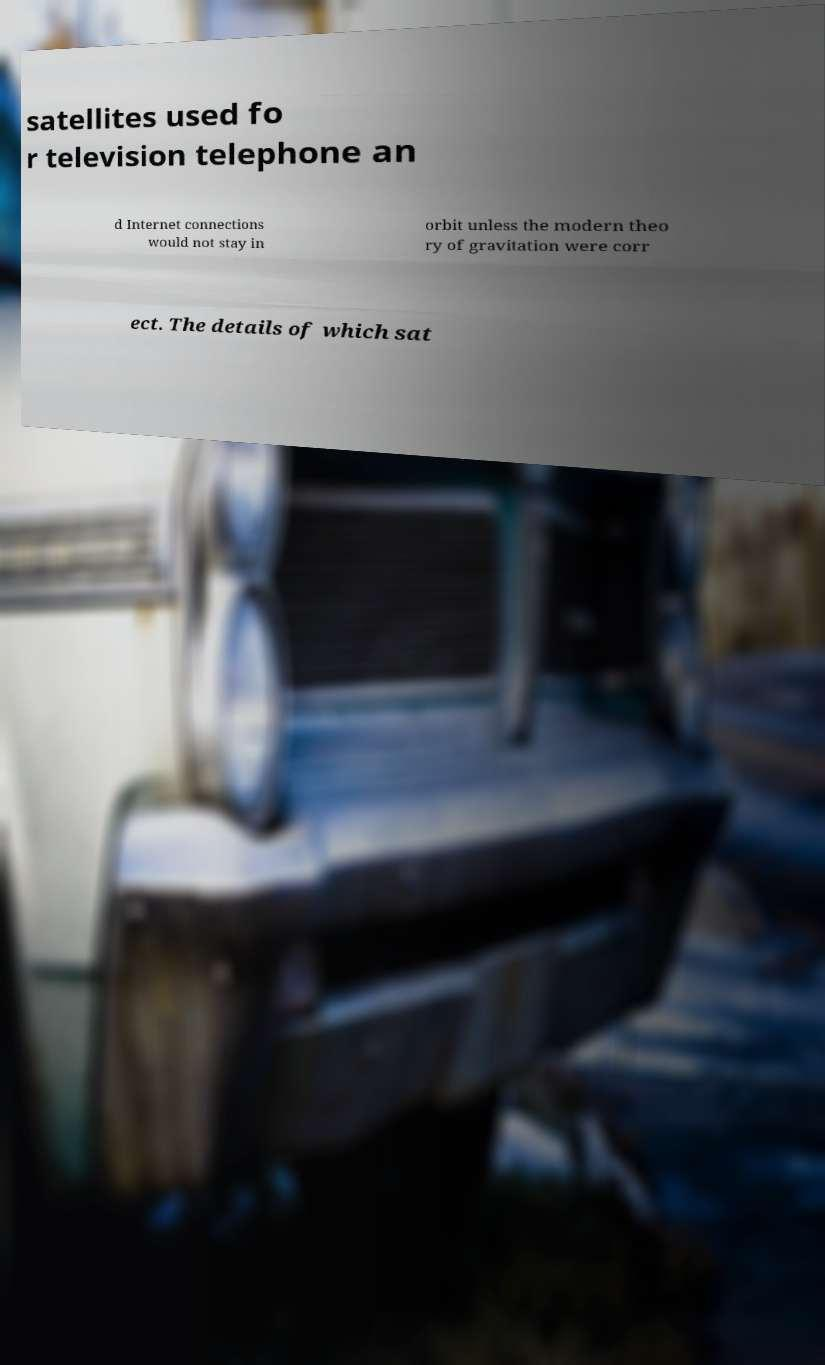Please read and relay the text visible in this image. What does it say? satellites used fo r television telephone an d Internet connections would not stay in orbit unless the modern theo ry of gravitation were corr ect. The details of which sat 